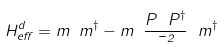<formula> <loc_0><loc_0><loc_500><loc_500>H _ { e f f } ^ { d } = m \ m ^ { \dagger } - m \ \frac { P \ P ^ { \dagger } } { \mu ^ { 2 } } \ m ^ { \dagger }</formula> 